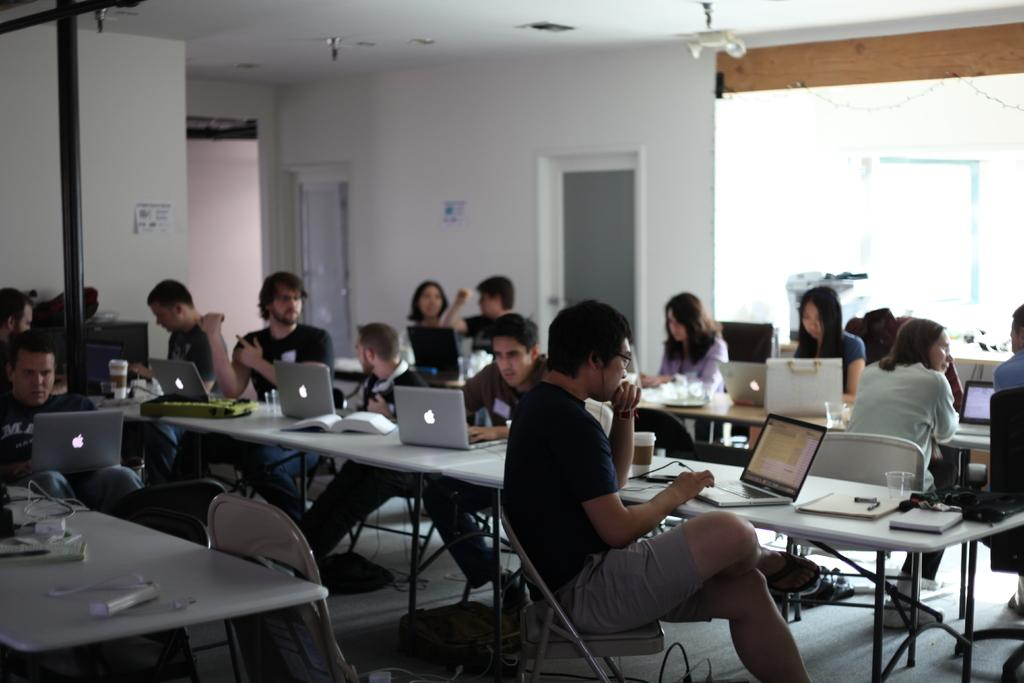What are the people in the image doing? The people in the image are sitting on chairs. Where are the chairs located in relation to the table? The chairs are in front of the table. What can be seen on the table in the image? There are systems (likely electronic devices) and books on the table. Can you see a plough in the image? No, there is no plough present in the image. What color is the rose on the table? There is no rose present in the image. 